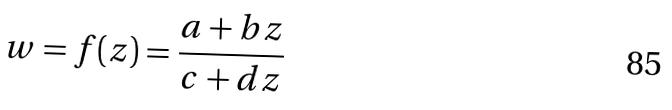Convert formula to latex. <formula><loc_0><loc_0><loc_500><loc_500>w = f ( z ) = \frac { a + b z } { c + d z }</formula> 